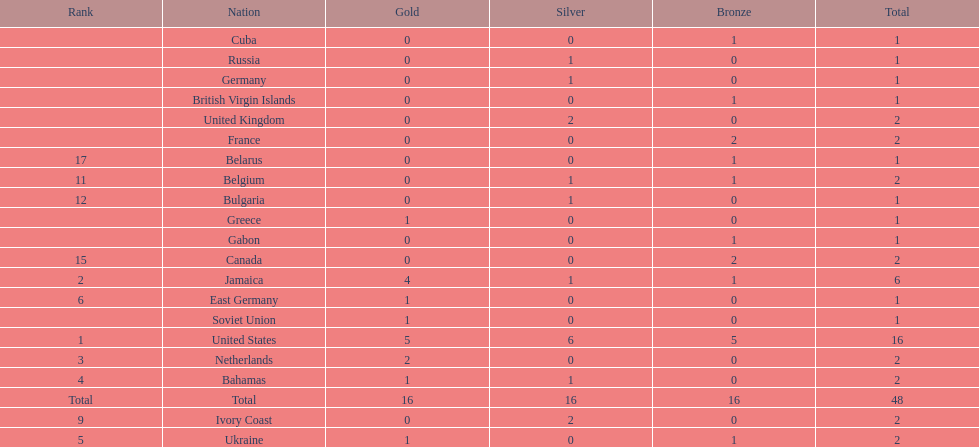How many nations won no gold medals? 12. 